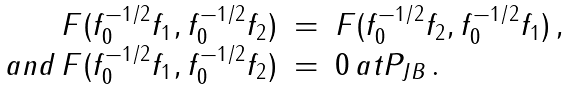<formula> <loc_0><loc_0><loc_500><loc_500>\begin{array} { r l l } { { F ( f _ { 0 } ^ { - 1 / 2 } f _ { 1 } , f _ { 0 } ^ { - 1 / 2 } f _ { 2 } ) } } & { = } & { { F ( f _ { 0 } ^ { - 1 / 2 } f _ { 2 } , f _ { 0 } ^ { - 1 / 2 } f _ { 1 } ) \, , } } \\ { { a n d \, F ( f _ { 0 } ^ { - 1 / 2 } f _ { 1 } , f _ { 0 } ^ { - 1 / 2 } f _ { 2 } ) } } & { = } & { { 0 \, a t P _ { J B } \, . } } \end{array}</formula> 